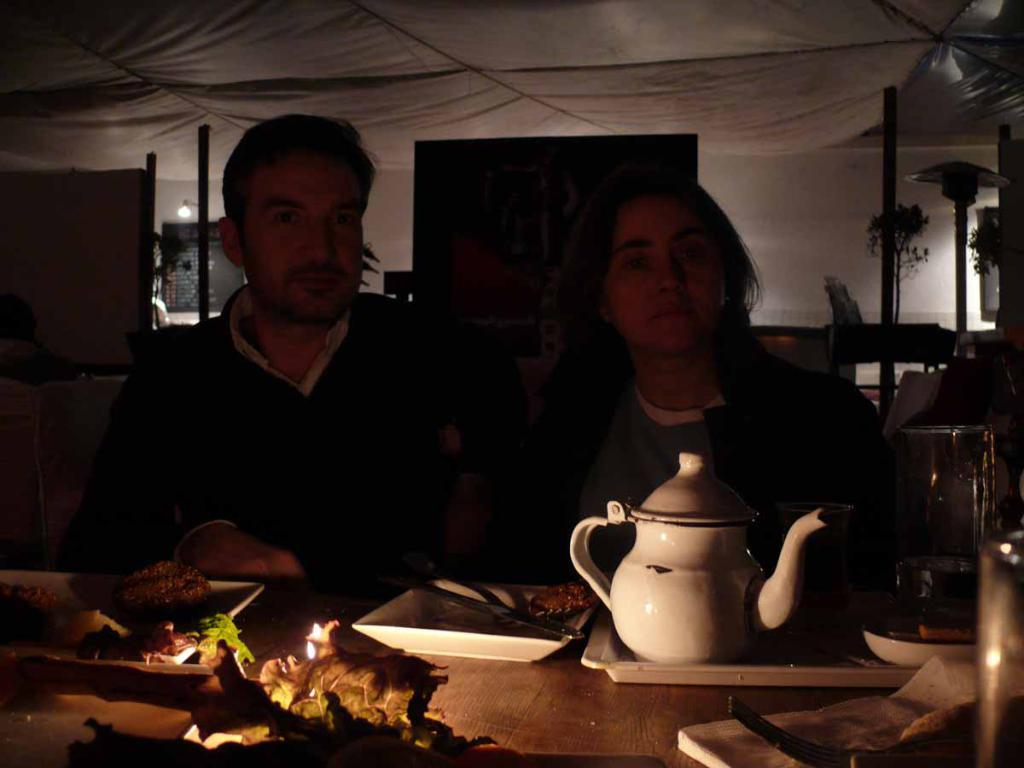What is the man in the image doing? The man is sitting in the image. What is the man wearing? The man is wearing a shirt. Who is sitting beside the man? There is a girl sitting beside the man. What can be seen on the table in the image? There are dining items on the table. How many wishes does the man have in the image? There is no mention of wishes in the image, so it cannot be determined. 